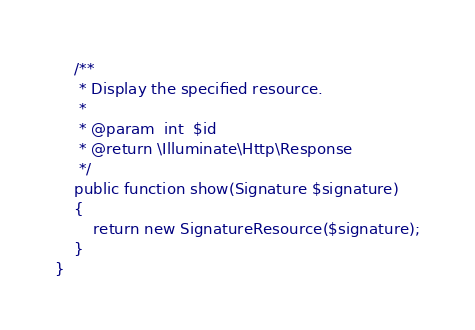Convert code to text. <code><loc_0><loc_0><loc_500><loc_500><_PHP_>
    /**
     * Display the specified resource.
     *
     * @param  int  $id
     * @return \Illuminate\Http\Response
     */
    public function show(Signature $signature)
    {
        return new SignatureResource($signature);
    }
}</code> 